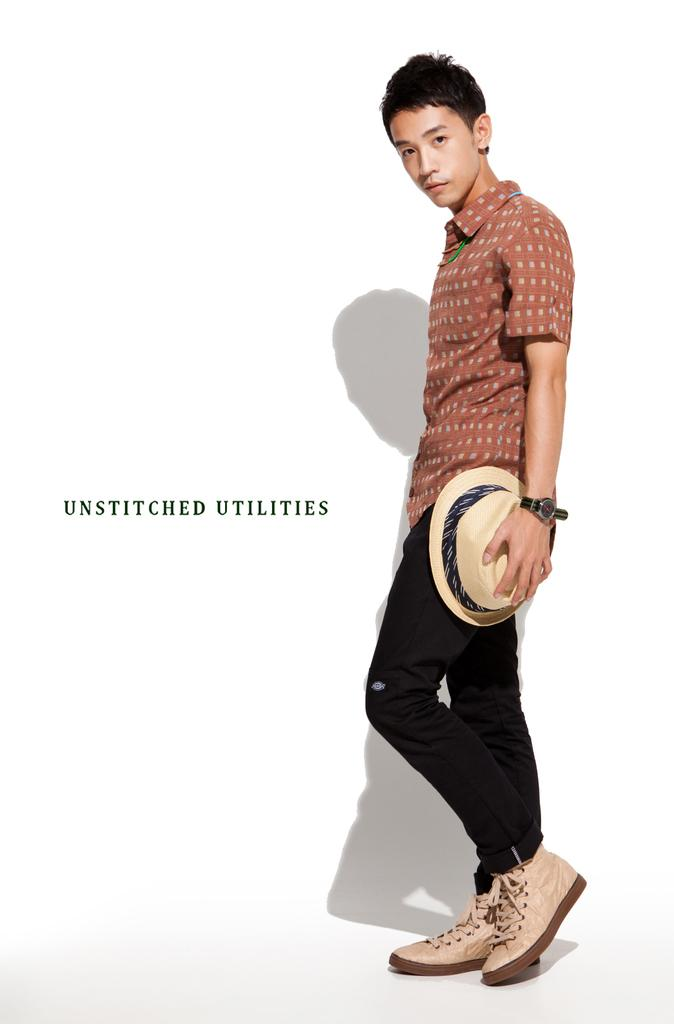What is the main subject of the image? There is a person standing in the image. What is the person holding in his hand? The person is holding a hat in his hand. Can you describe the text visible in the image? There is some text on a white surface in the image. What is the purpose of the competition taking place in the image? There is no competition present in the image; it features a person holding a hat and some text on a white surface. 